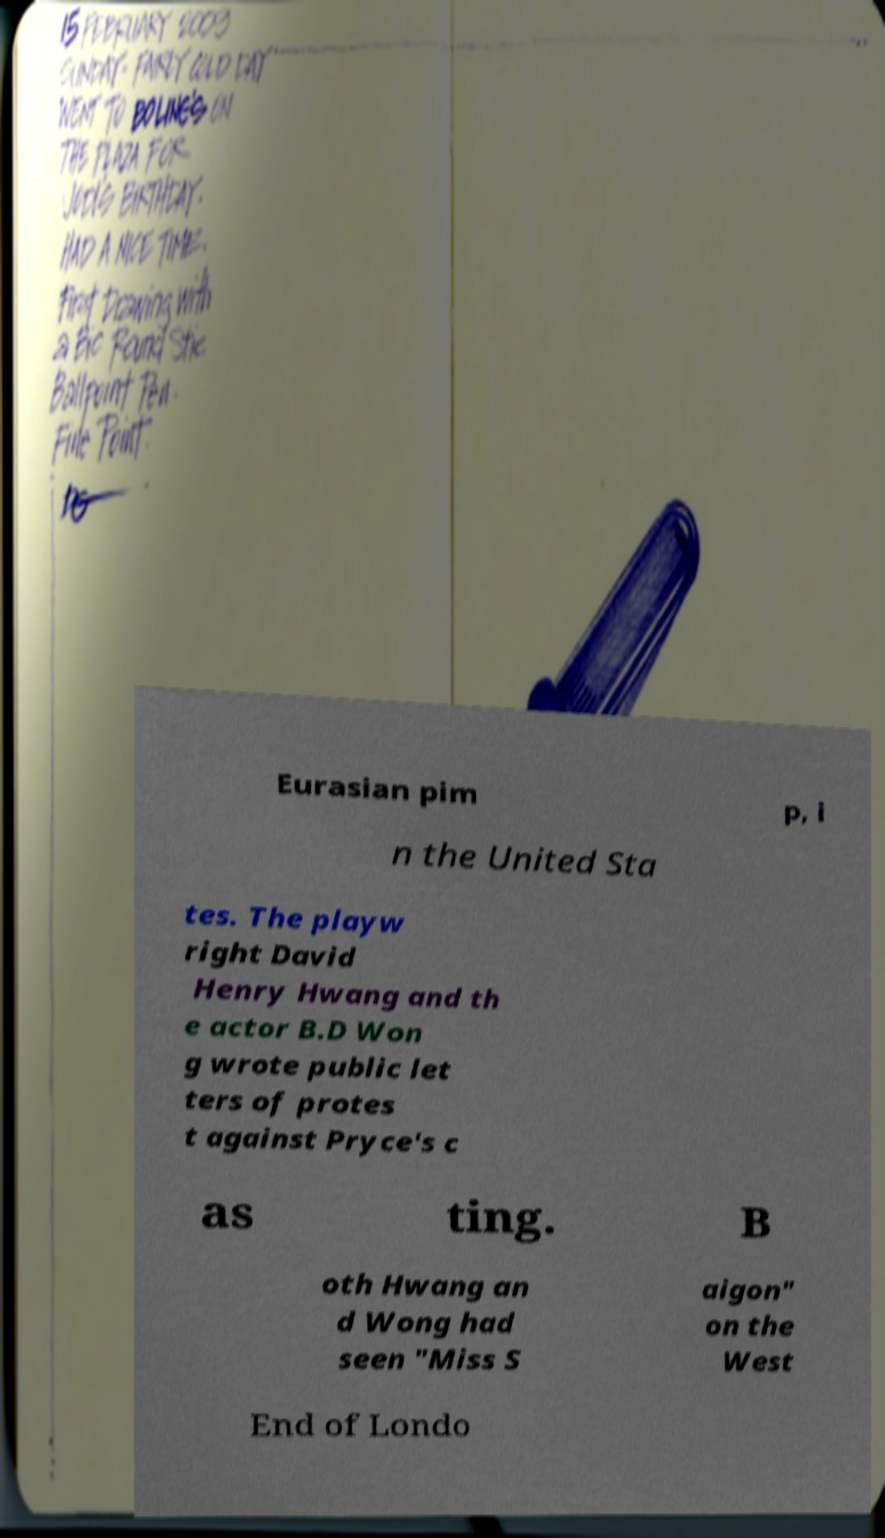Can you read and provide the text displayed in the image?This photo seems to have some interesting text. Can you extract and type it out for me? Eurasian pim p, i n the United Sta tes. The playw right David Henry Hwang and th e actor B.D Won g wrote public let ters of protes t against Pryce's c as ting. B oth Hwang an d Wong had seen "Miss S aigon" on the West End of Londo 